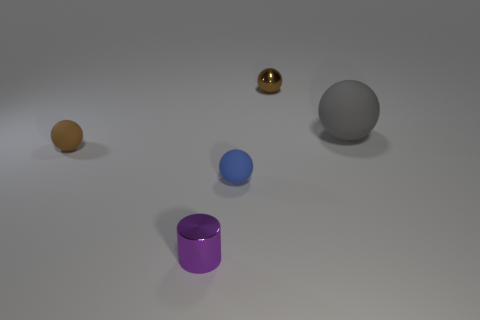Are there any other small purple shiny things that have the same shape as the small purple shiny thing? In the image provided, there is only one small purple shiny object, which appears to be a cylinder. There are no other objects with the exact same shape and color as this one. 